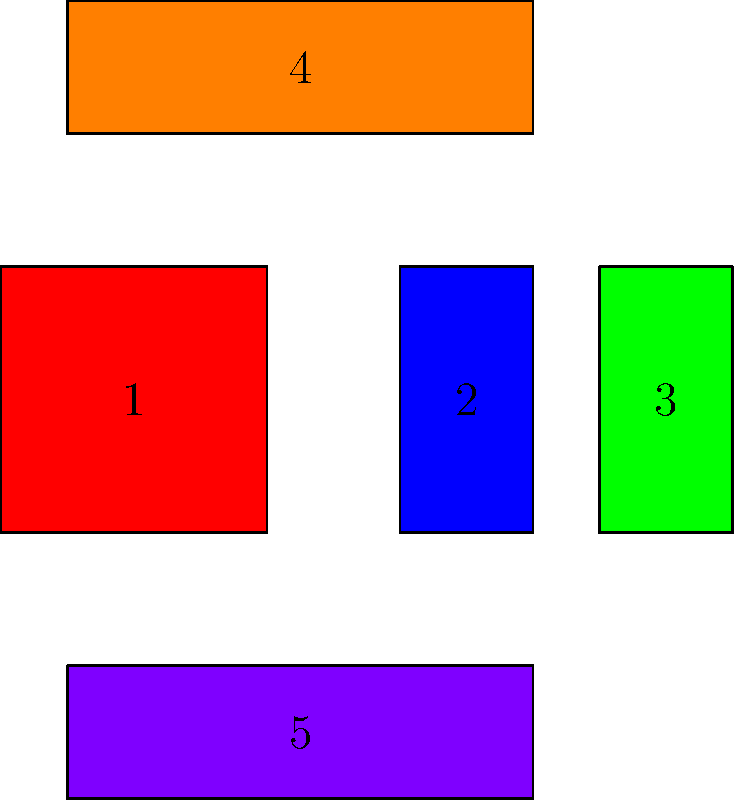In the given manga panel layout, how does the arrangement of panels contribute to the visual pacing of an action scene? To analyze how the panel layout contributes to the visual pacing of an action scene, let's break it down step-by-step:

1. Panel sizes and shapes:
   - Panel 1 is large and square, suggesting a significant moment or establishing shot.
   - Panels 2 and 3 are tall and narrow, indicating quick, vertical action or movement.
   - Panels 4 and 5 are wide and short, implying a broader view or horizontal movement.

2. Panel arrangement:
   - The layout follows a Z-pattern (1 → 2 → 3 → 4 → 5), guiding the reader's eye naturally.
   - The central column (2 and 3) creates a vertical flow, potentially showing rapid action.

3. Pacing interpretation:
   - The large Panel 1 allows for a moment of pause or setup.
   - The quick transition to narrow Panels 2 and 3 suggests accelerated action or tension.
   - The wider Panels 4 and 5 might indicate a broader view of the action's consequences or a deceleration.

4. Visual rhythm:
   - The alternating panel sizes create a visual rhythm that mimics the ebb and flow of action.
   - The layout suggests a pattern of setup (1) → quick action (2, 3) → reaction or result (4, 5).

5. Reader engagement:
   - The varied panel sizes and shapes keep the reader's eye moving, maintaining engagement.
   - The layout encourages a specific reading speed that matches the intended pacing of the action.

This panel arrangement effectively controls the visual pacing by guiding the reader's eye movement and attention, creating a dynamic flow that mirrors the intensity and speed of the action being depicted.
Answer: Dynamic flow: setup → rapid action → consequence 